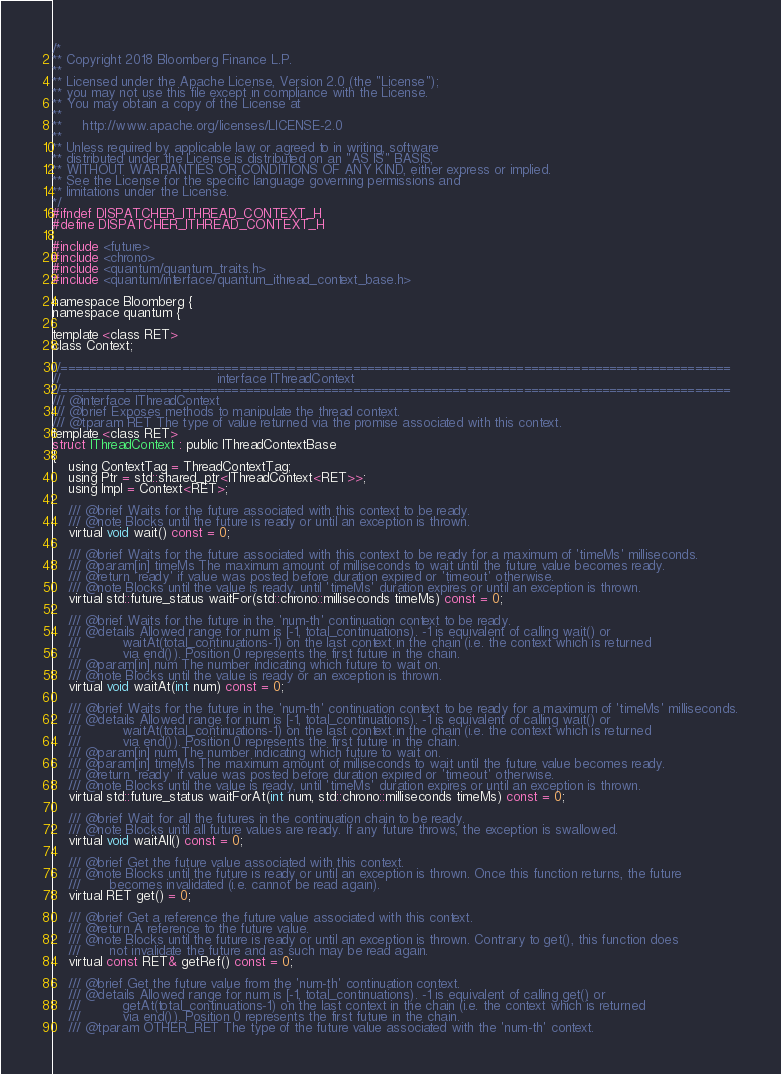<code> <loc_0><loc_0><loc_500><loc_500><_C_>/*
** Copyright 2018 Bloomberg Finance L.P.
**
** Licensed under the Apache License, Version 2.0 (the "License");
** you may not use this file except in compliance with the License.
** You may obtain a copy of the License at
**
**     http://www.apache.org/licenses/LICENSE-2.0
**
** Unless required by applicable law or agreed to in writing, software
** distributed under the License is distributed on an "AS IS" BASIS,
** WITHOUT WARRANTIES OR CONDITIONS OF ANY KIND, either express or implied.
** See the License for the specific language governing permissions and
** limitations under the License.
*/
#ifndef DISPATCHER_ITHREAD_CONTEXT_H
#define DISPATCHER_ITHREAD_CONTEXT_H

#include <future>
#include <chrono>
#include <quantum/quantum_traits.h>
#include <quantum/interface/quantum_ithread_context_base.h>

namespace Bloomberg {
namespace quantum {

template <class RET>
class Context;

//==============================================================================================
//                                      interface IThreadContext
//==============================================================================================
/// @interface IThreadContext
/// @brief Exposes methods to manipulate the thread context.
/// @tparam RET The type of value returned via the promise associated with this context.
template <class RET>
struct IThreadContext : public IThreadContextBase
{
    using ContextTag = ThreadContextTag;
    using Ptr = std::shared_ptr<IThreadContext<RET>>;
    using Impl = Context<RET>;
    
    /// @brief Waits for the future associated with this context to be ready.
    /// @note Blocks until the future is ready or until an exception is thrown.
    virtual void wait() const = 0;
    
    /// @brief Waits for the future associated with this context to be ready for a maximum of 'timeMs' milliseconds.
    /// @param[in] timeMs The maximum amount of milliseconds to wait until the future value becomes ready.
    /// @return 'ready' if value was posted before duration expired or 'timeout' otherwise.
    /// @note Blocks until the value is ready, until 'timeMs' duration expires or until an exception is thrown.
    virtual std::future_status waitFor(std::chrono::milliseconds timeMs) const = 0;
    
    /// @brief Waits for the future in the 'num-th' continuation context to be ready.
    /// @details Allowed range for num is [-1, total_continuations). -1 is equivalent of calling wait() or
    ///          waitAt(total_continuations-1) on the last context in the chain (i.e. the context which is returned
    ///          via end()). Position 0 represents the first future in the chain.
    /// @param[in] num The number indicating which future to wait on.
    /// @note Blocks until the value is ready or an exception is thrown.
    virtual void waitAt(int num) const = 0;
    
    /// @brief Waits for the future in the 'num-th' continuation context to be ready for a maximum of 'timeMs' milliseconds.
    /// @details Allowed range for num is [-1, total_continuations). -1 is equivalent of calling wait() or
    ///          waitAt(total_continuations-1) on the last context in the chain (i.e. the context which is returned
    ///          via end()). Position 0 represents the first future in the chain.
    /// @param[in] num The number indicating which future to wait on.
    /// @param[in] timeMs The maximum amount of milliseconds to wait until the future value becomes ready.
    /// @return 'ready' if value was posted before duration expired or 'timeout' otherwise.
    /// @note Blocks until the value is ready, until 'timeMs' duration expires or until an exception is thrown.
    virtual std::future_status waitForAt(int num, std::chrono::milliseconds timeMs) const = 0;
    
    /// @brief Wait for all the futures in the continuation chain to be ready.
    /// @note Blocks until all future values are ready. If any future throws, the exception is swallowed.
    virtual void waitAll() const = 0;
    
    /// @brief Get the future value associated with this context.
    /// @note Blocks until the future is ready or until an exception is thrown. Once this function returns, the future
    ///       becomes invalidated (i.e. cannot be read again).
    virtual RET get() = 0;
    
    /// @brief Get a reference the future value associated with this context.
    /// @return A reference to the future value.
    /// @note Blocks until the future is ready or until an exception is thrown. Contrary to get(), this function does
    ///       not invalidate the future and as such may be read again.
    virtual const RET& getRef() const = 0;
    
    /// @brief Get the future value from the 'num-th' continuation context.
    /// @details Allowed range for num is [-1, total_continuations). -1 is equivalent of calling get() or
    ///          getAt(total_continuations-1) on the last context in the chain (i.e. the context which is returned
    ///          via end()). Position 0 represents the first future in the chain.
    /// @tparam OTHER_RET The type of the future value associated with the 'num-th' context.</code> 